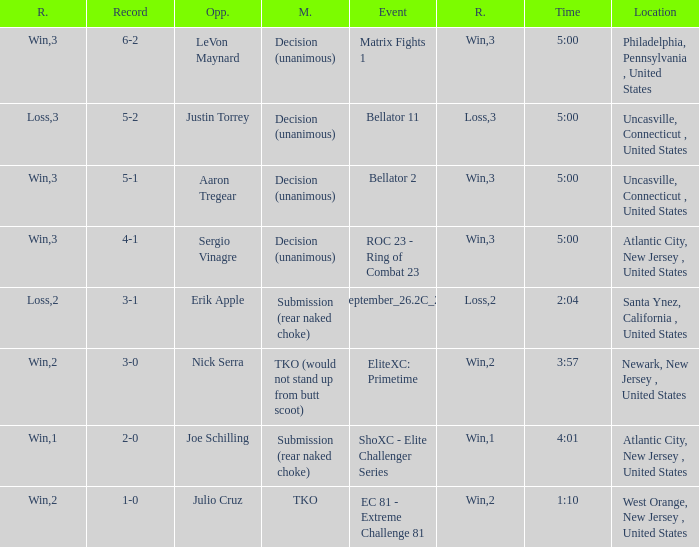What was the round that Sergio Vinagre had a time of 5:00? 3.0. 